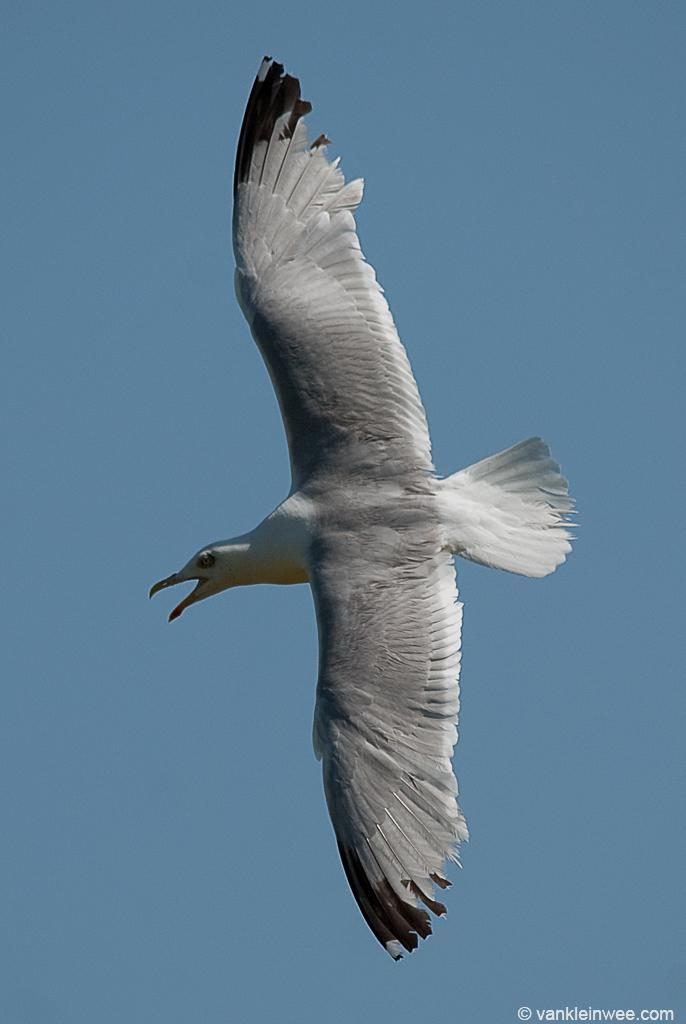What is flying in the air in the image? There is a bird in the air in the image. What can be seen in the background of the image? There is sky visible in the background of the image. What is located at the bottom of the image? There is some text at the bottom of the image. How many cows are grazing in the plantation shown in the image? There are no cows or plantations present in the image; it features a bird in the air and sky in the background. 